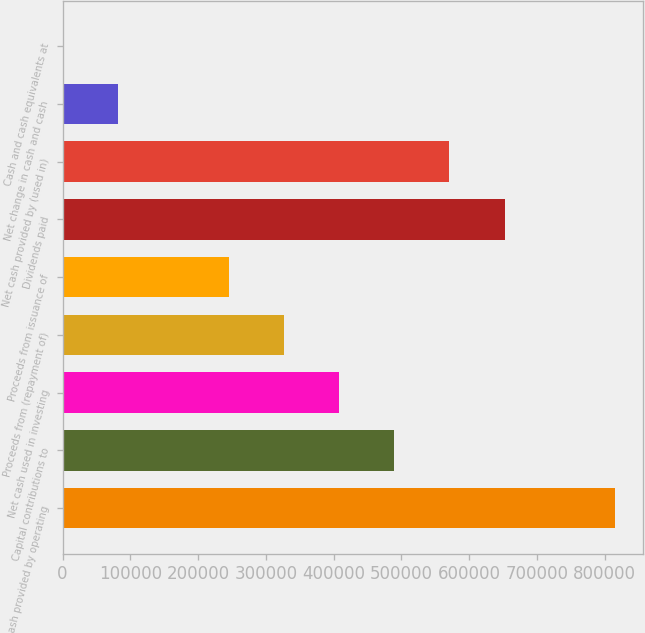<chart> <loc_0><loc_0><loc_500><loc_500><bar_chart><fcel>Net cash provided by operating<fcel>Capital contributions to<fcel>Net cash used in investing<fcel>Proceeds from (repayment of)<fcel>Proceeds from issuance of<fcel>Dividends paid<fcel>Net cash provided by (used in)<fcel>Net change in cash and cash<fcel>Cash and cash equivalents at<nl><fcel>815209<fcel>489366<fcel>407906<fcel>326445<fcel>244984<fcel>652288<fcel>570827<fcel>82062.7<fcel>602<nl></chart> 